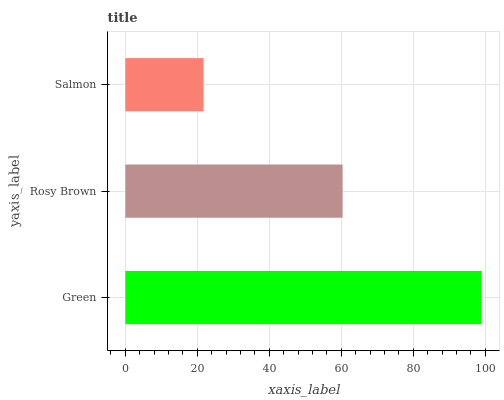Is Salmon the minimum?
Answer yes or no. Yes. Is Green the maximum?
Answer yes or no. Yes. Is Rosy Brown the minimum?
Answer yes or no. No. Is Rosy Brown the maximum?
Answer yes or no. No. Is Green greater than Rosy Brown?
Answer yes or no. Yes. Is Rosy Brown less than Green?
Answer yes or no. Yes. Is Rosy Brown greater than Green?
Answer yes or no. No. Is Green less than Rosy Brown?
Answer yes or no. No. Is Rosy Brown the high median?
Answer yes or no. Yes. Is Rosy Brown the low median?
Answer yes or no. Yes. Is Green the high median?
Answer yes or no. No. Is Green the low median?
Answer yes or no. No. 